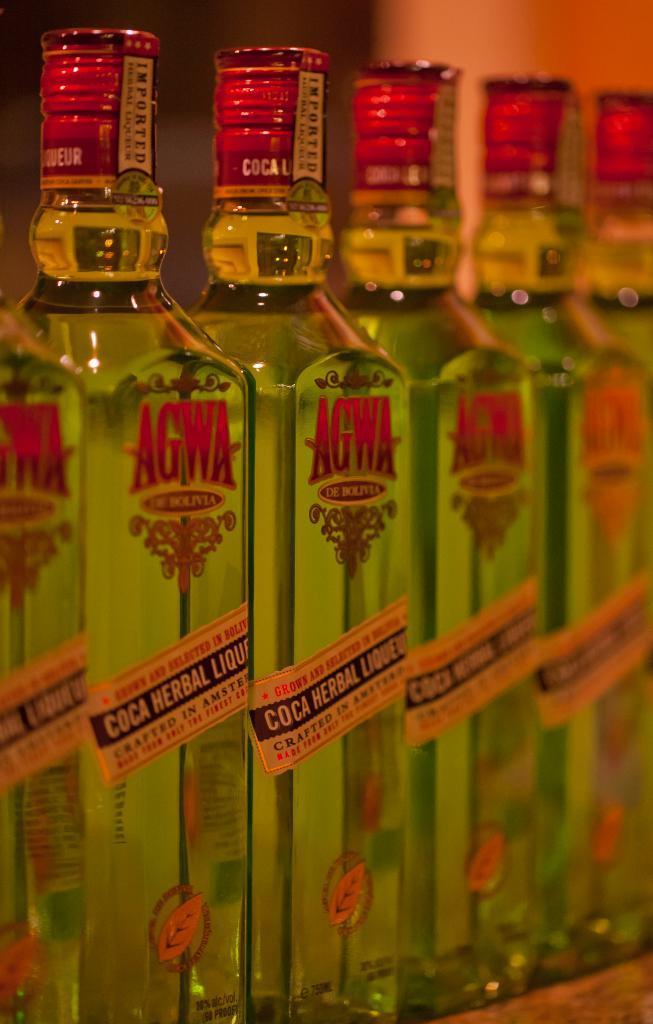In one or two sentences, can you explain what this image depicts? This picture is mainly highlighted with bottles named "AGWA" 